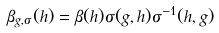Convert formula to latex. <formula><loc_0><loc_0><loc_500><loc_500>\beta _ { g , \sigma } ( h ) = \beta ( h ) \sigma ( g , h ) \sigma ^ { - 1 } ( h , g )</formula> 